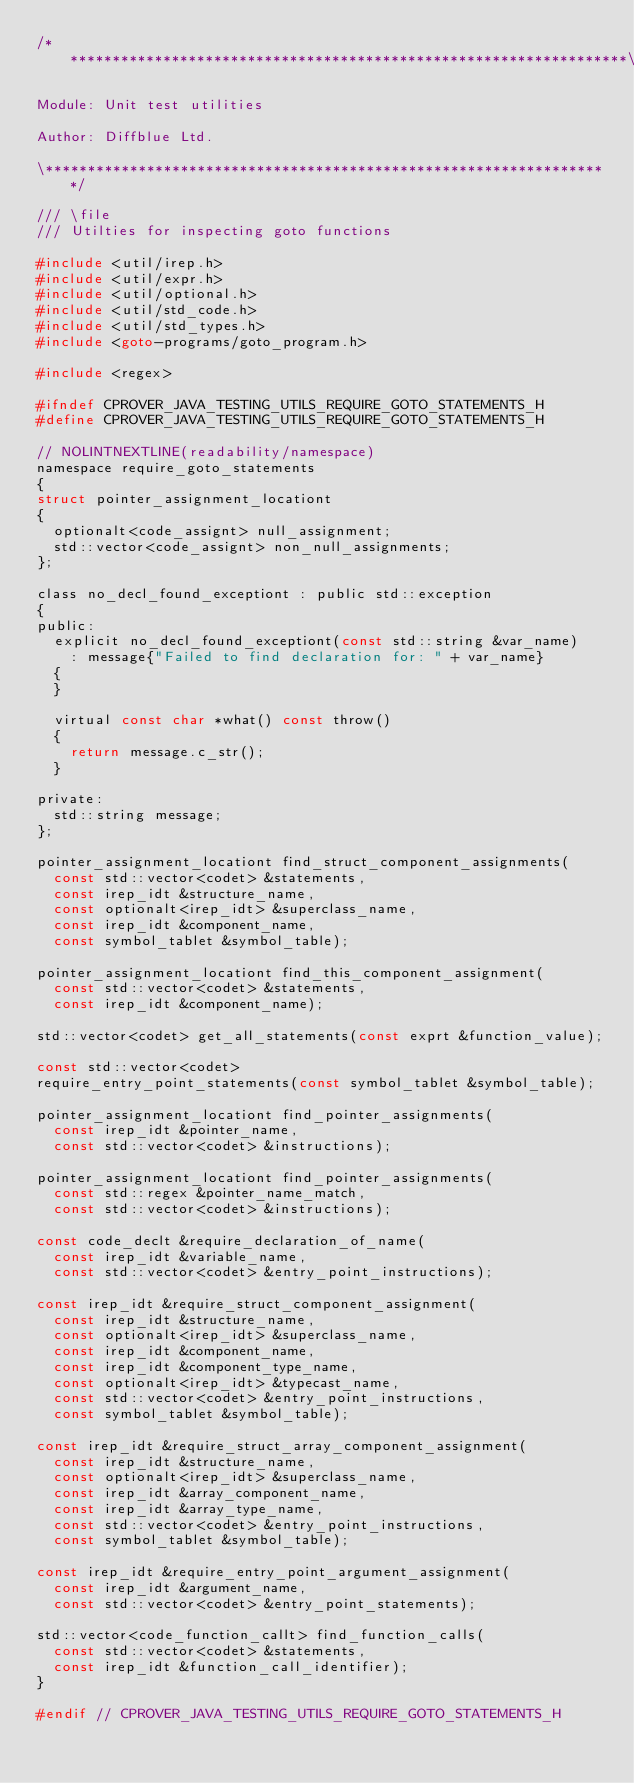<code> <loc_0><loc_0><loc_500><loc_500><_C_>/*******************************************************************\

Module: Unit test utilities

Author: Diffblue Ltd.

\*******************************************************************/

/// \file
/// Utilties for inspecting goto functions

#include <util/irep.h>
#include <util/expr.h>
#include <util/optional.h>
#include <util/std_code.h>
#include <util/std_types.h>
#include <goto-programs/goto_program.h>

#include <regex>

#ifndef CPROVER_JAVA_TESTING_UTILS_REQUIRE_GOTO_STATEMENTS_H
#define CPROVER_JAVA_TESTING_UTILS_REQUIRE_GOTO_STATEMENTS_H

// NOLINTNEXTLINE(readability/namespace)
namespace require_goto_statements
{
struct pointer_assignment_locationt
{
  optionalt<code_assignt> null_assignment;
  std::vector<code_assignt> non_null_assignments;
};

class no_decl_found_exceptiont : public std::exception
{
public:
  explicit no_decl_found_exceptiont(const std::string &var_name)
    : message{"Failed to find declaration for: " + var_name}
  {
  }

  virtual const char *what() const throw()
  {
    return message.c_str();
  }

private:
  std::string message;
};

pointer_assignment_locationt find_struct_component_assignments(
  const std::vector<codet> &statements,
  const irep_idt &structure_name,
  const optionalt<irep_idt> &superclass_name,
  const irep_idt &component_name,
  const symbol_tablet &symbol_table);

pointer_assignment_locationt find_this_component_assignment(
  const std::vector<codet> &statements,
  const irep_idt &component_name);

std::vector<codet> get_all_statements(const exprt &function_value);

const std::vector<codet>
require_entry_point_statements(const symbol_tablet &symbol_table);

pointer_assignment_locationt find_pointer_assignments(
  const irep_idt &pointer_name,
  const std::vector<codet> &instructions);

pointer_assignment_locationt find_pointer_assignments(
  const std::regex &pointer_name_match,
  const std::vector<codet> &instructions);

const code_declt &require_declaration_of_name(
  const irep_idt &variable_name,
  const std::vector<codet> &entry_point_instructions);

const irep_idt &require_struct_component_assignment(
  const irep_idt &structure_name,
  const optionalt<irep_idt> &superclass_name,
  const irep_idt &component_name,
  const irep_idt &component_type_name,
  const optionalt<irep_idt> &typecast_name,
  const std::vector<codet> &entry_point_instructions,
  const symbol_tablet &symbol_table);

const irep_idt &require_struct_array_component_assignment(
  const irep_idt &structure_name,
  const optionalt<irep_idt> &superclass_name,
  const irep_idt &array_component_name,
  const irep_idt &array_type_name,
  const std::vector<codet> &entry_point_instructions,
  const symbol_tablet &symbol_table);

const irep_idt &require_entry_point_argument_assignment(
  const irep_idt &argument_name,
  const std::vector<codet> &entry_point_statements);

std::vector<code_function_callt> find_function_calls(
  const std::vector<codet> &statements,
  const irep_idt &function_call_identifier);
}

#endif // CPROVER_JAVA_TESTING_UTILS_REQUIRE_GOTO_STATEMENTS_H
</code> 